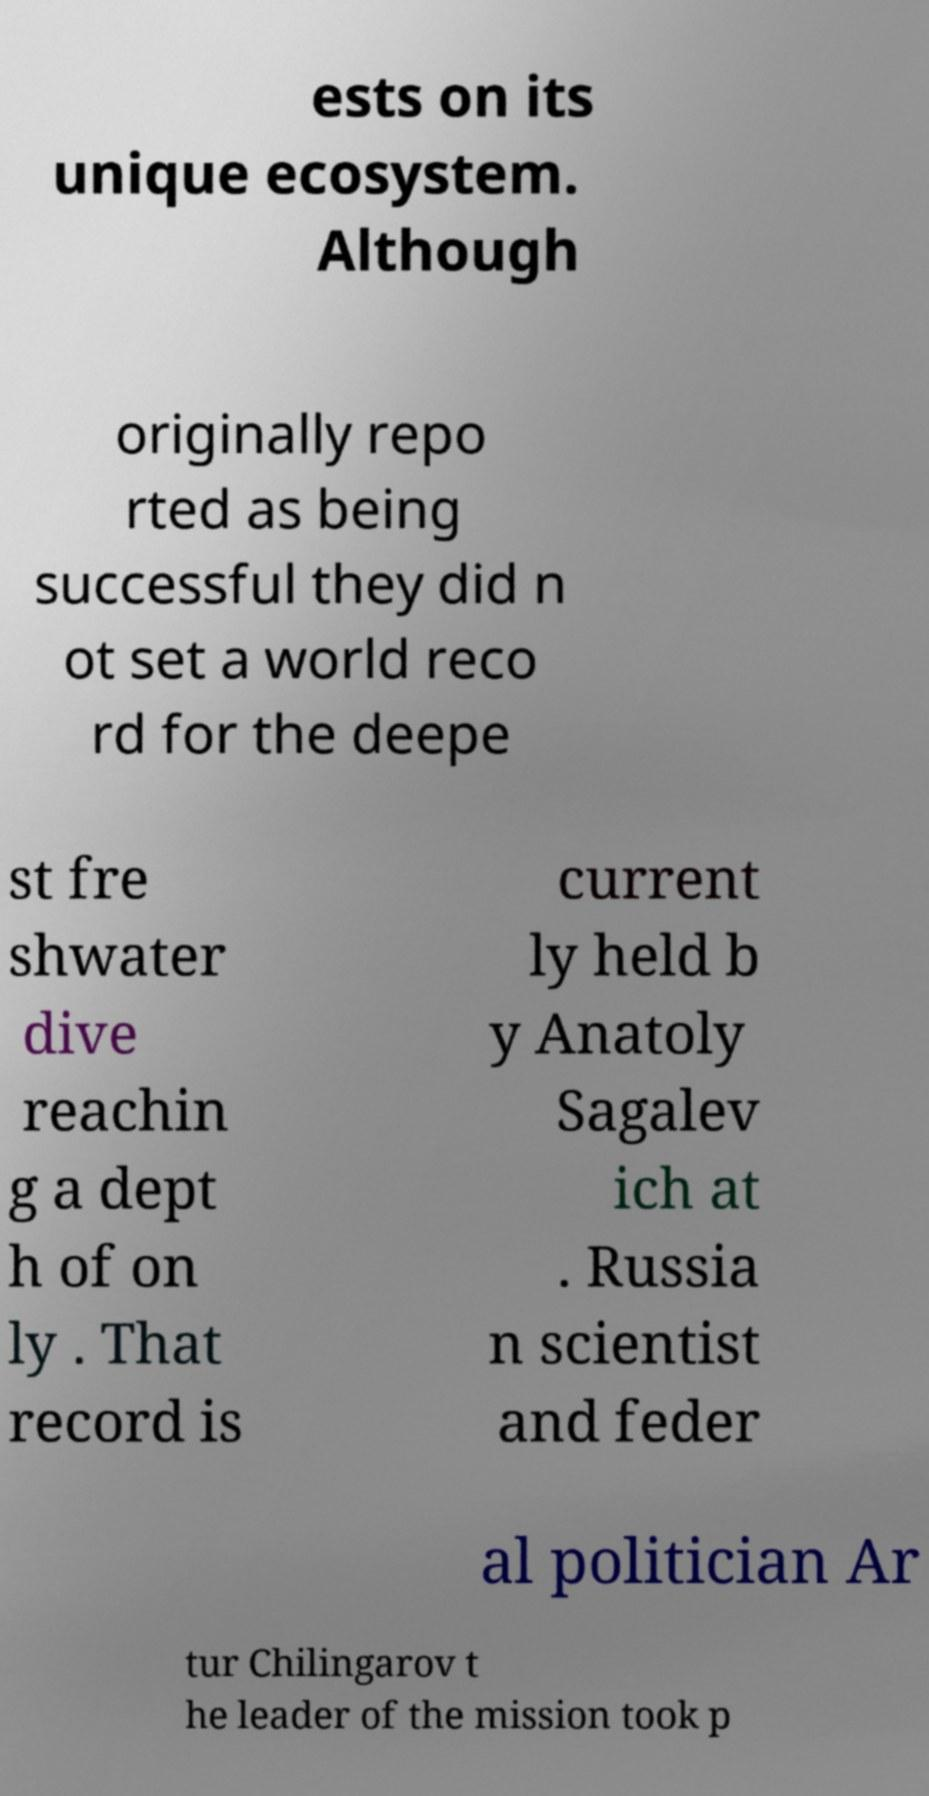Please identify and transcribe the text found in this image. ests on its unique ecosystem. Although originally repo rted as being successful they did n ot set a world reco rd for the deepe st fre shwater dive reachin g a dept h of on ly . That record is current ly held b y Anatoly Sagalev ich at . Russia n scientist and feder al politician Ar tur Chilingarov t he leader of the mission took p 